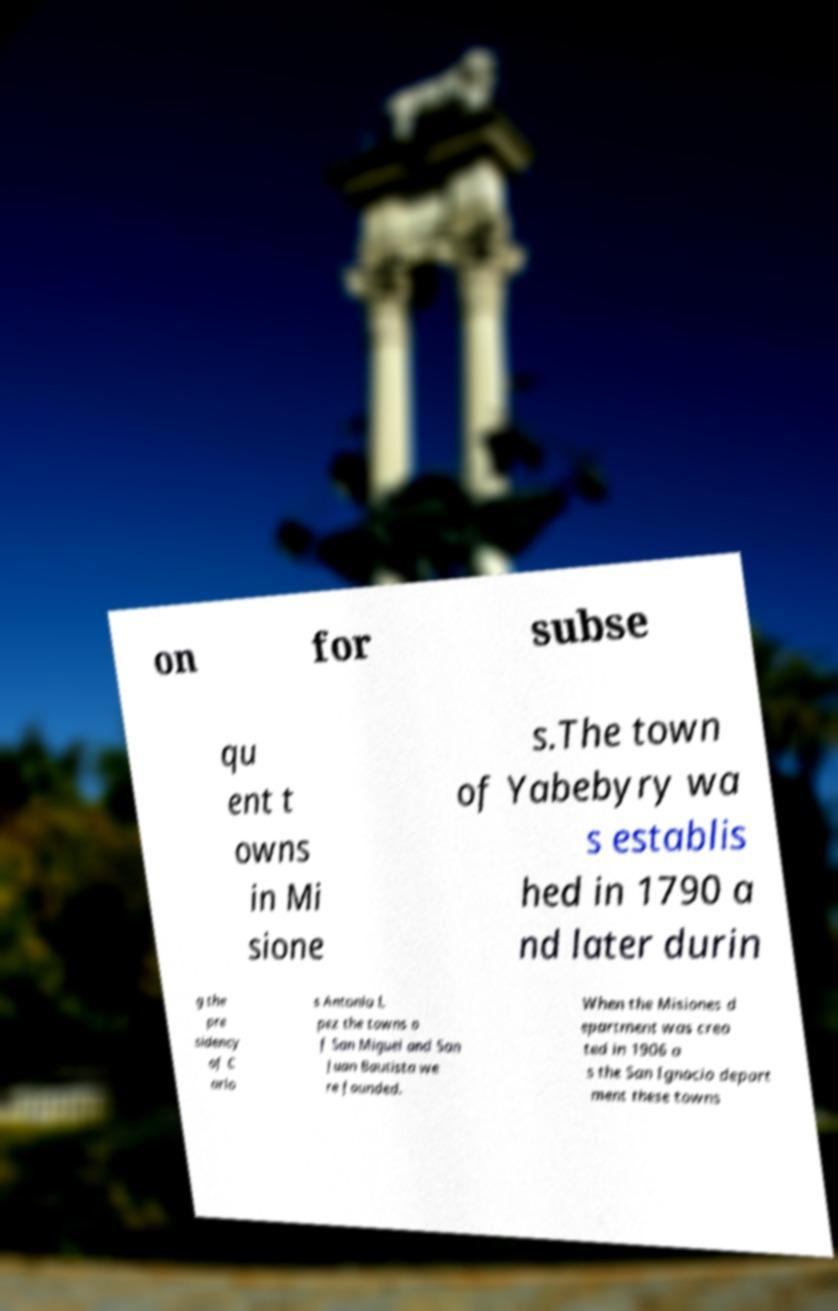There's text embedded in this image that I need extracted. Can you transcribe it verbatim? on for subse qu ent t owns in Mi sione s.The town of Yabebyry wa s establis hed in 1790 a nd later durin g the pre sidency of C arlo s Antonio L pez the towns o f San Miguel and San Juan Bautista we re founded. When the Misiones d epartment was crea ted in 1906 a s the San Ignacio depart ment these towns 